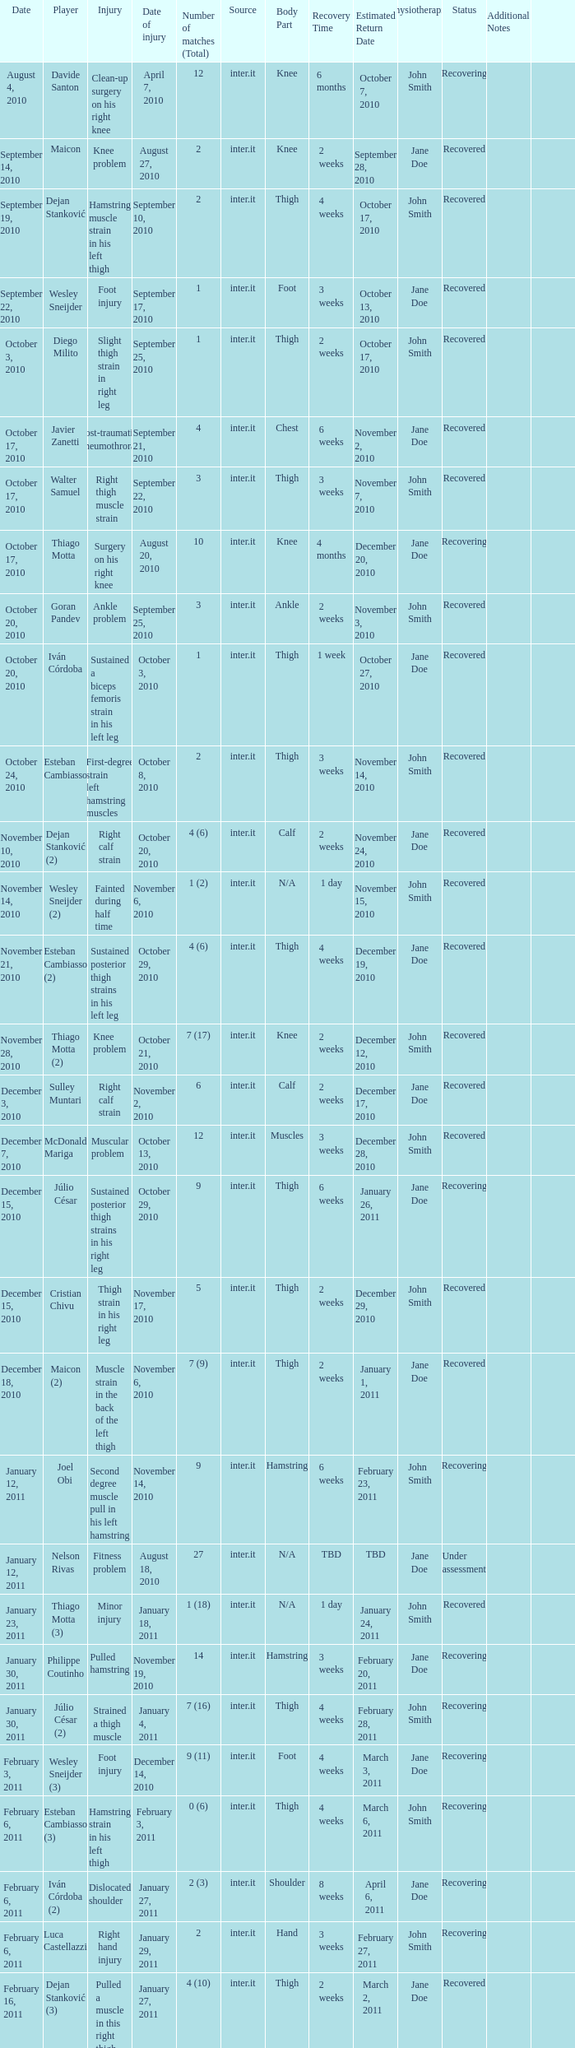What is the date of injury when the injury is foot injury and the number of matches (total) is 1? September 17, 2010. 